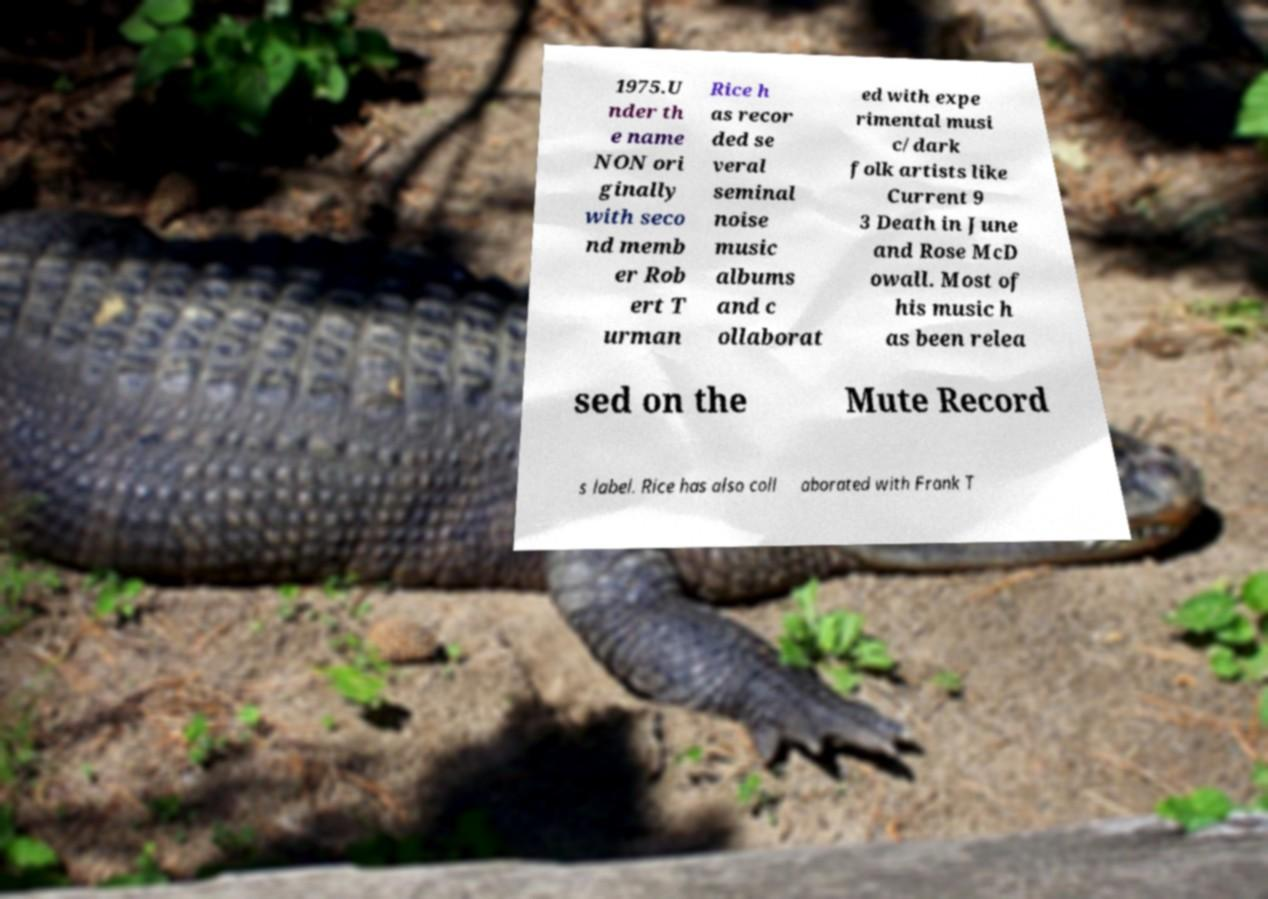Could you extract and type out the text from this image? 1975.U nder th e name NON ori ginally with seco nd memb er Rob ert T urman Rice h as recor ded se veral seminal noise music albums and c ollaborat ed with expe rimental musi c/dark folk artists like Current 9 3 Death in June and Rose McD owall. Most of his music h as been relea sed on the Mute Record s label. Rice has also coll aborated with Frank T 